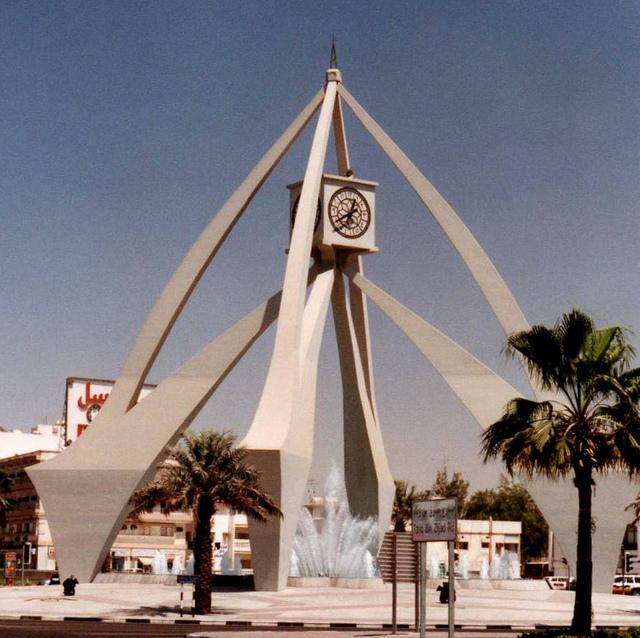Is there water?
Concise answer only. Yes. What is this structure?
Quick response, please. Clock. What does the building in the background appear to be?
Concise answer only. Hotel. 